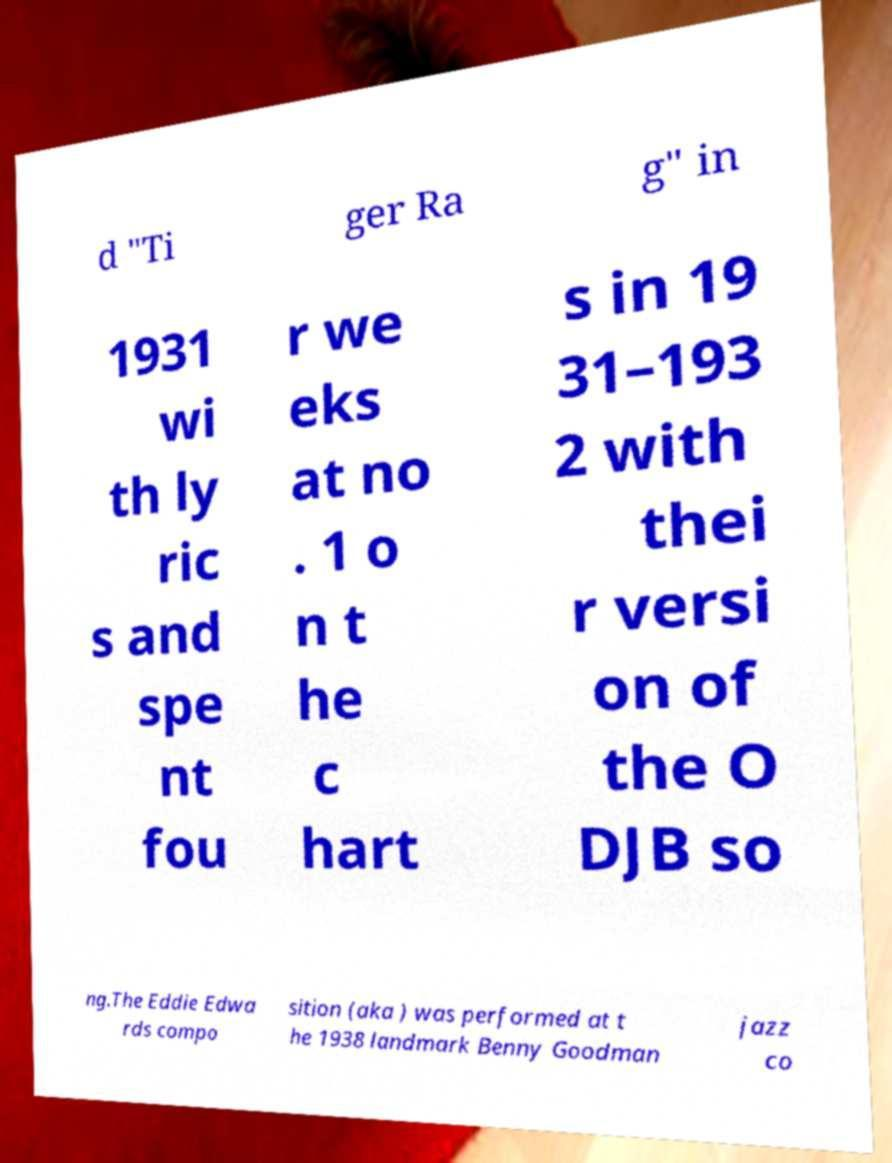For documentation purposes, I need the text within this image transcribed. Could you provide that? d "Ti ger Ra g" in 1931 wi th ly ric s and spe nt fou r we eks at no . 1 o n t he c hart s in 19 31–193 2 with thei r versi on of the O DJB so ng.The Eddie Edwa rds compo sition (aka ) was performed at t he 1938 landmark Benny Goodman jazz co 